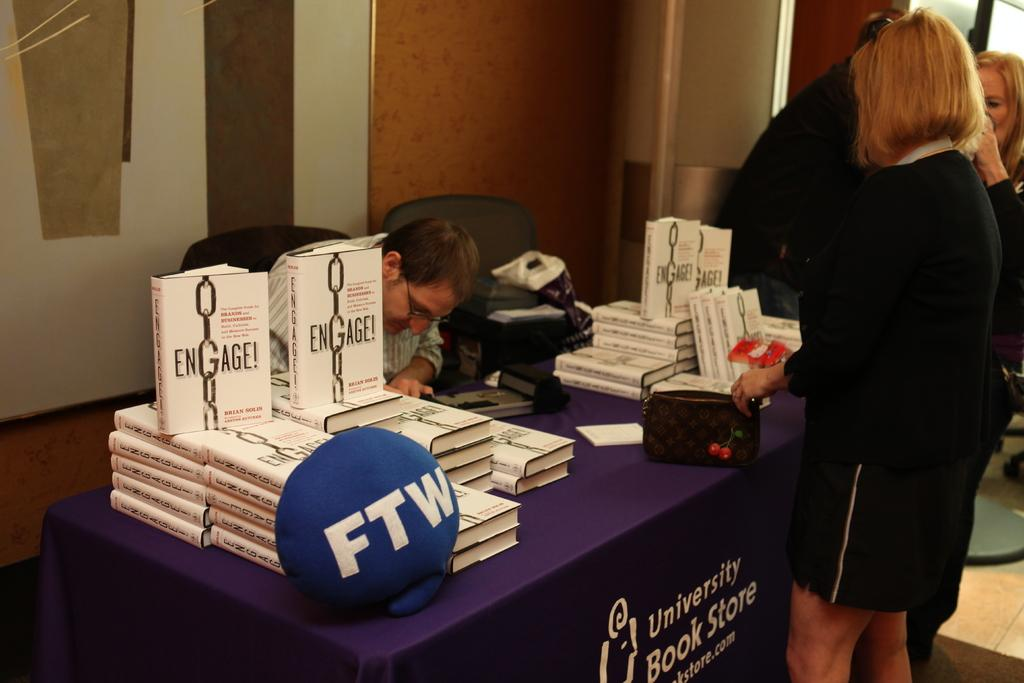What type of items can be seen in the image? There are books and objects on the table in the image. Can you describe the people in the image? There are people in the image, and one person is sitting on a chair. What is visible in the background of the image? There is a wall visible in the image. Are there any shoes visible in the wilderness in the image? There is no wilderness or shoes present in the image. What type of school can be seen in the image? There is no school present in the image. 